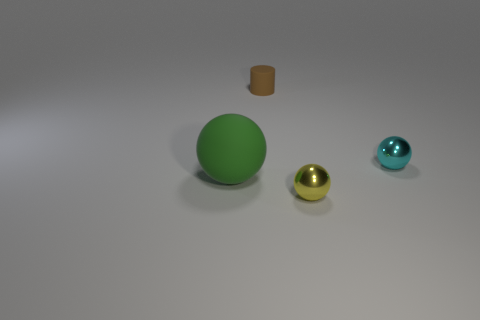Is there anything else that has the same size as the green thing?
Make the answer very short. No. There is a tiny sphere that is behind the object to the left of the thing that is behind the cyan metallic object; what is its material?
Offer a terse response. Metal. What is the sphere in front of the green matte object made of?
Offer a terse response. Metal. Is the yellow shiny ball the same size as the green sphere?
Your answer should be compact. No. What number of other tiny brown cylinders have the same material as the brown cylinder?
Keep it short and to the point. 0. There is another rubber thing that is the same shape as the yellow object; what is its size?
Keep it short and to the point. Large. There is a small metallic thing that is left of the tiny cyan object; is it the same shape as the small rubber thing?
Provide a short and direct response. No. There is a object that is to the right of the small sphere in front of the large rubber ball; what is its shape?
Your answer should be very brief. Sphere. Are there any other things that are the same shape as the tiny yellow thing?
Your answer should be compact. Yes. There is another tiny object that is the same shape as the cyan metallic thing; what is its color?
Your response must be concise. Yellow. 